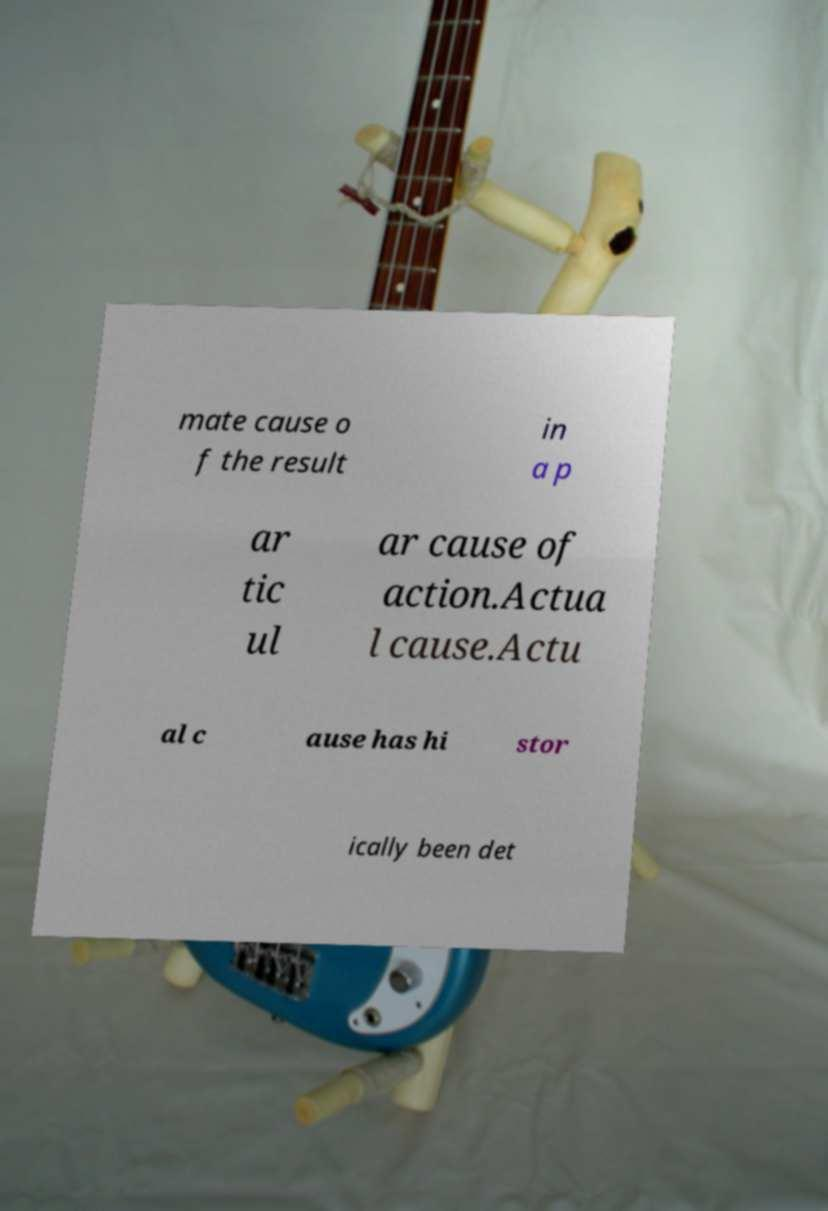Could you assist in decoding the text presented in this image and type it out clearly? mate cause o f the result in a p ar tic ul ar cause of action.Actua l cause.Actu al c ause has hi stor ically been det 